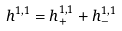<formula> <loc_0><loc_0><loc_500><loc_500>h ^ { 1 , 1 } = h _ { + } ^ { 1 , 1 } + h _ { - } ^ { 1 , 1 }</formula> 